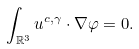<formula> <loc_0><loc_0><loc_500><loc_500>\int _ { \mathbb { R } ^ { 3 } } u ^ { c , \gamma } \cdot \nabla \varphi = 0 .</formula> 